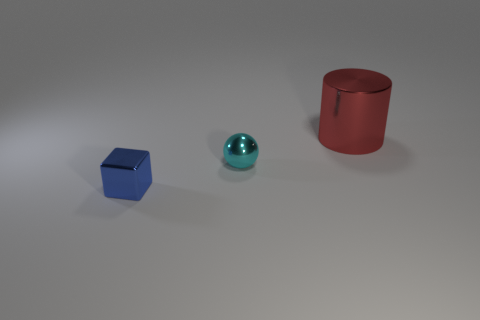Add 2 large blue things. How many objects exist? 5 Subtract 1 cylinders. How many cylinders are left? 0 Subtract all tiny green matte cylinders. Subtract all small cyan metal balls. How many objects are left? 2 Add 1 blue things. How many blue things are left? 2 Add 1 big metallic spheres. How many big metallic spheres exist? 1 Subtract 0 green balls. How many objects are left? 3 Subtract all green cylinders. Subtract all red spheres. How many cylinders are left? 1 